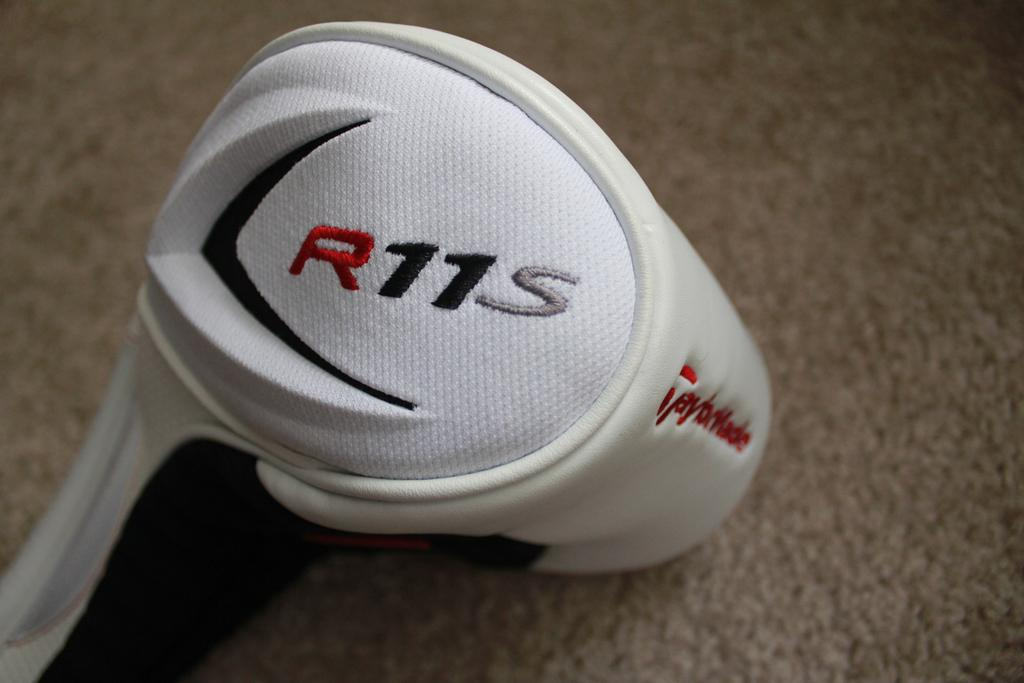What object can be seen in the image? There is a bag in the image. What type of flooring is visible in the image? There is a carpet on the floor in the image. What is the condition of the zephyr in the image? There is no mention of a zephyr in the image, so we cannot determine its condition. 